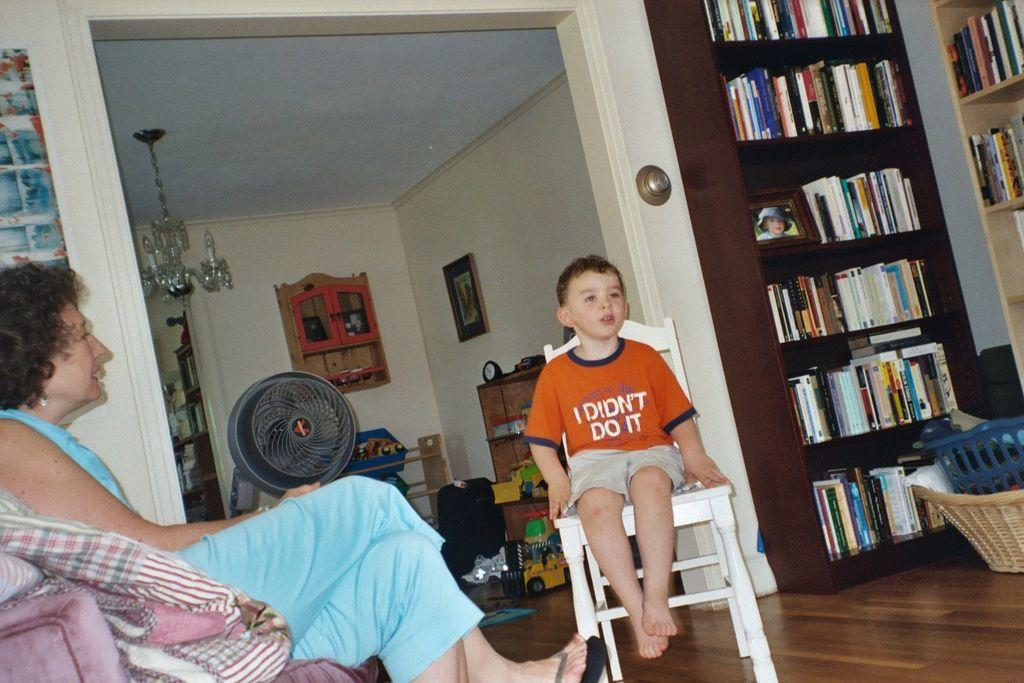<image>
Render a clear and concise summary of the photo. A woman and a child wearing a shirt that says I didn't do it. 